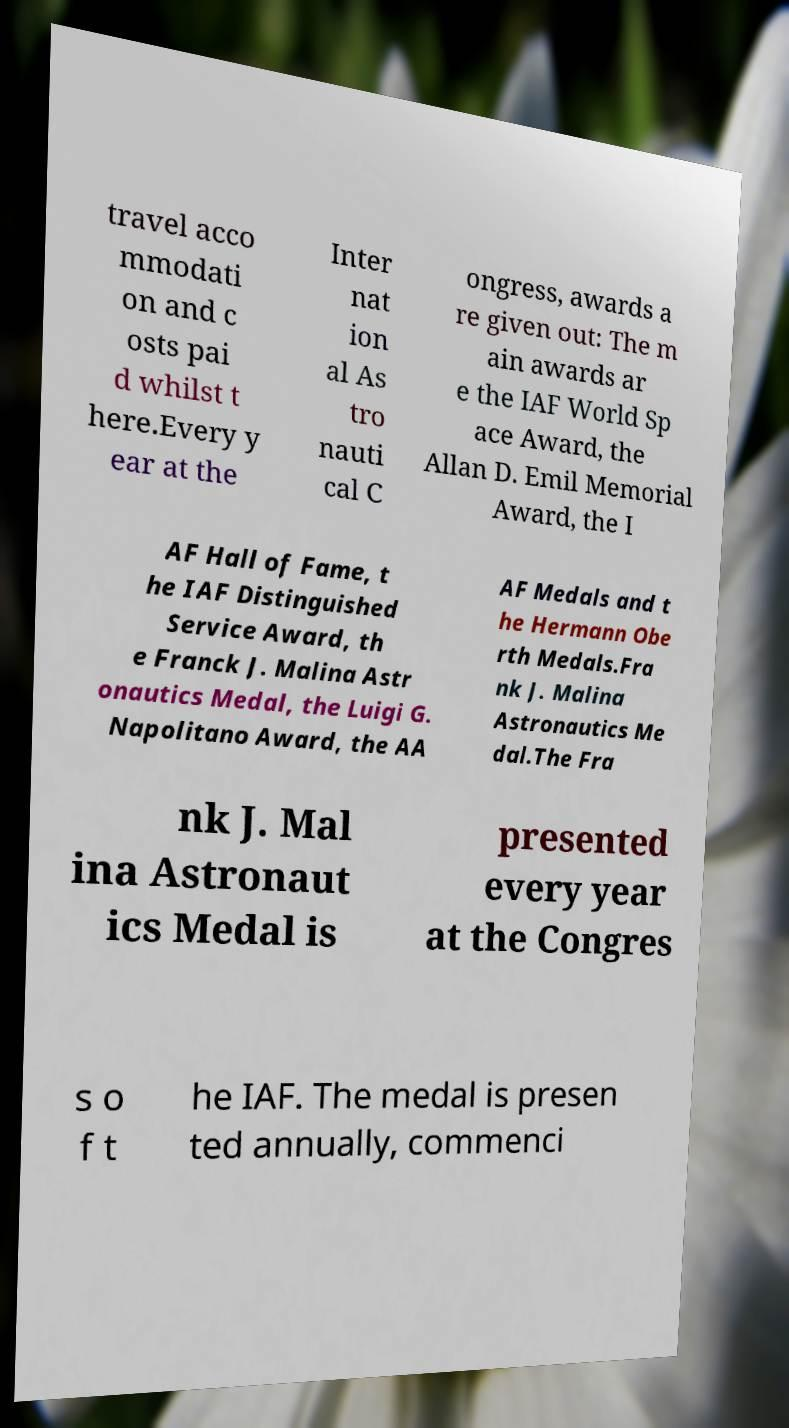What messages or text are displayed in this image? I need them in a readable, typed format. travel acco mmodati on and c osts pai d whilst t here.Every y ear at the Inter nat ion al As tro nauti cal C ongress, awards a re given out: The m ain awards ar e the IAF World Sp ace Award, the Allan D. Emil Memorial Award, the I AF Hall of Fame, t he IAF Distinguished Service Award, th e Franck J. Malina Astr onautics Medal, the Luigi G. Napolitano Award, the AA AF Medals and t he Hermann Obe rth Medals.Fra nk J. Malina Astronautics Me dal.The Fra nk J. Mal ina Astronaut ics Medal is presented every year at the Congres s o f t he IAF. The medal is presen ted annually, commenci 